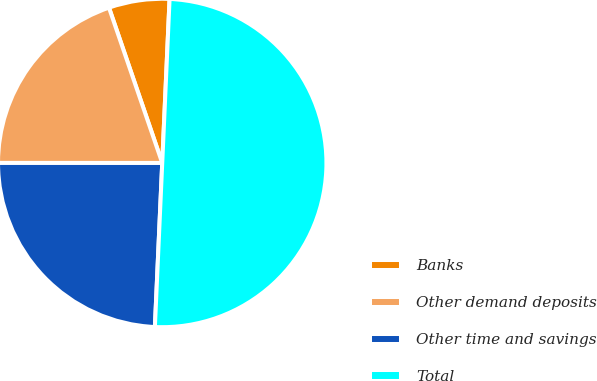Convert chart to OTSL. <chart><loc_0><loc_0><loc_500><loc_500><pie_chart><fcel>Banks<fcel>Other demand deposits<fcel>Other time and savings<fcel>Total<nl><fcel>5.97%<fcel>19.74%<fcel>24.29%<fcel>50.0%<nl></chart> 